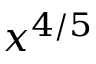<formula> <loc_0><loc_0><loc_500><loc_500>x ^ { 4 / 5 }</formula> 